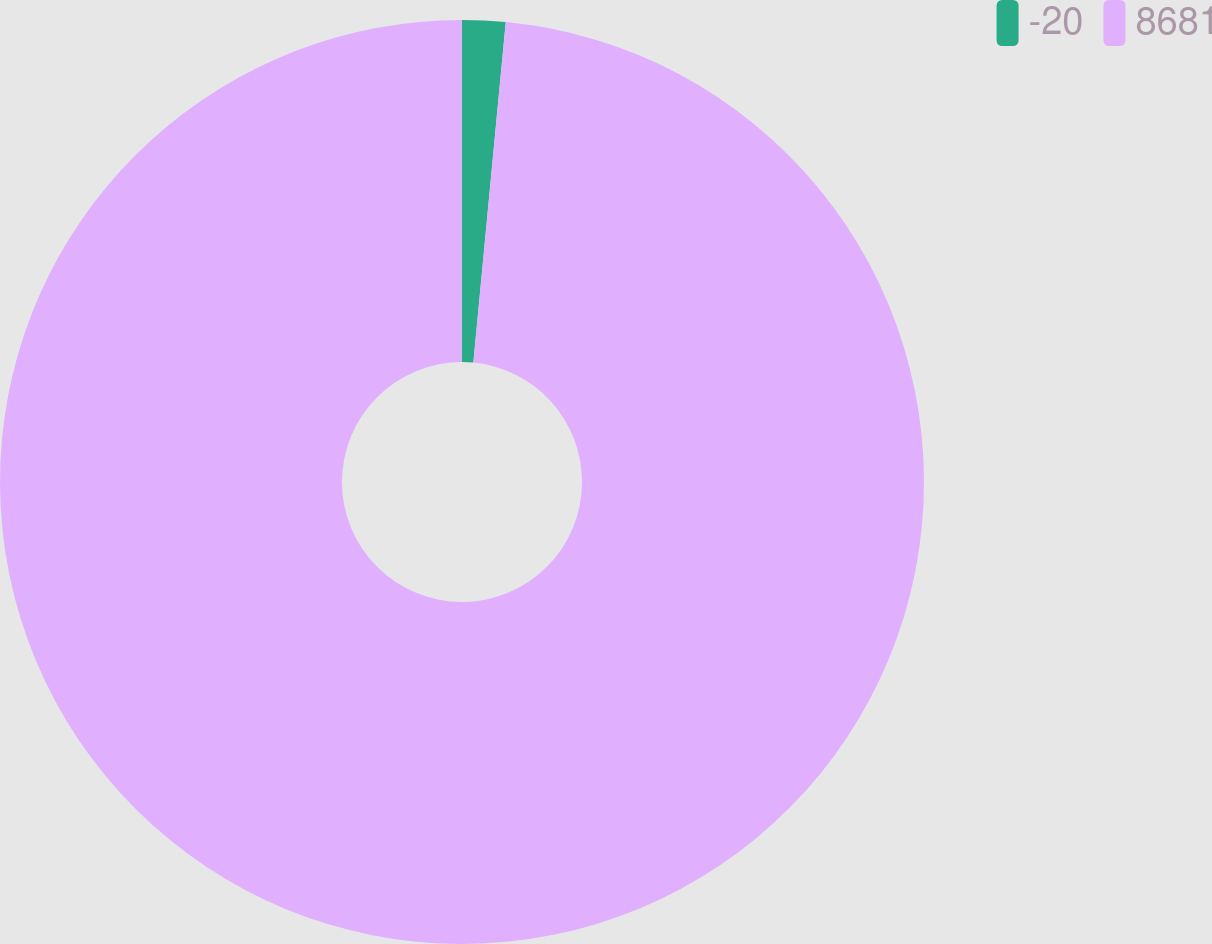Convert chart to OTSL. <chart><loc_0><loc_0><loc_500><loc_500><pie_chart><fcel>-20<fcel>8681<nl><fcel>1.51%<fcel>98.49%<nl></chart> 